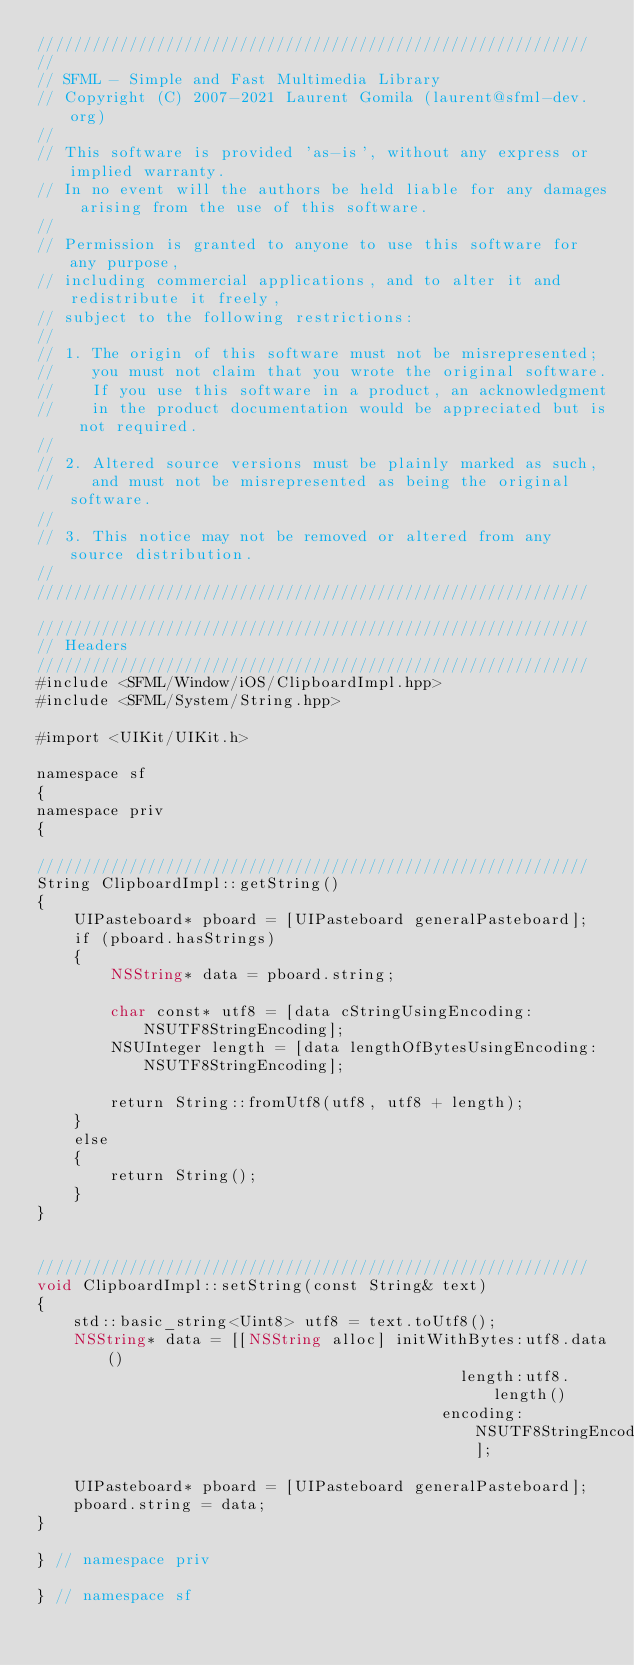<code> <loc_0><loc_0><loc_500><loc_500><_ObjectiveC_>////////////////////////////////////////////////////////////
//
// SFML - Simple and Fast Multimedia Library
// Copyright (C) 2007-2021 Laurent Gomila (laurent@sfml-dev.org)
//
// This software is provided 'as-is', without any express or implied warranty.
// In no event will the authors be held liable for any damages arising from the use of this software.
//
// Permission is granted to anyone to use this software for any purpose,
// including commercial applications, and to alter it and redistribute it freely,
// subject to the following restrictions:
//
// 1. The origin of this software must not be misrepresented;
//    you must not claim that you wrote the original software.
//    If you use this software in a product, an acknowledgment
//    in the product documentation would be appreciated but is not required.
//
// 2. Altered source versions must be plainly marked as such,
//    and must not be misrepresented as being the original software.
//
// 3. This notice may not be removed or altered from any source distribution.
//
////////////////////////////////////////////////////////////

////////////////////////////////////////////////////////////
// Headers
////////////////////////////////////////////////////////////
#include <SFML/Window/iOS/ClipboardImpl.hpp>
#include <SFML/System/String.hpp>

#import <UIKit/UIKit.h>

namespace sf
{
namespace priv
{

////////////////////////////////////////////////////////////
String ClipboardImpl::getString()
{
    UIPasteboard* pboard = [UIPasteboard generalPasteboard];
    if (pboard.hasStrings)
    {
        NSString* data = pboard.string;

        char const* utf8 = [data cStringUsingEncoding:NSUTF8StringEncoding];
        NSUInteger length = [data lengthOfBytesUsingEncoding:NSUTF8StringEncoding];

        return String::fromUtf8(utf8, utf8 + length);
    }
    else
    {
        return String();
    }
}


////////////////////////////////////////////////////////////
void ClipboardImpl::setString(const String& text)
{
    std::basic_string<Uint8> utf8 = text.toUtf8();
    NSString* data = [[NSString alloc] initWithBytes:utf8.data()
                                              length:utf8.length()
                                            encoding:NSUTF8StringEncoding];

    UIPasteboard* pboard = [UIPasteboard generalPasteboard];
    pboard.string = data;
}

} // namespace priv

} // namespace sf

</code> 